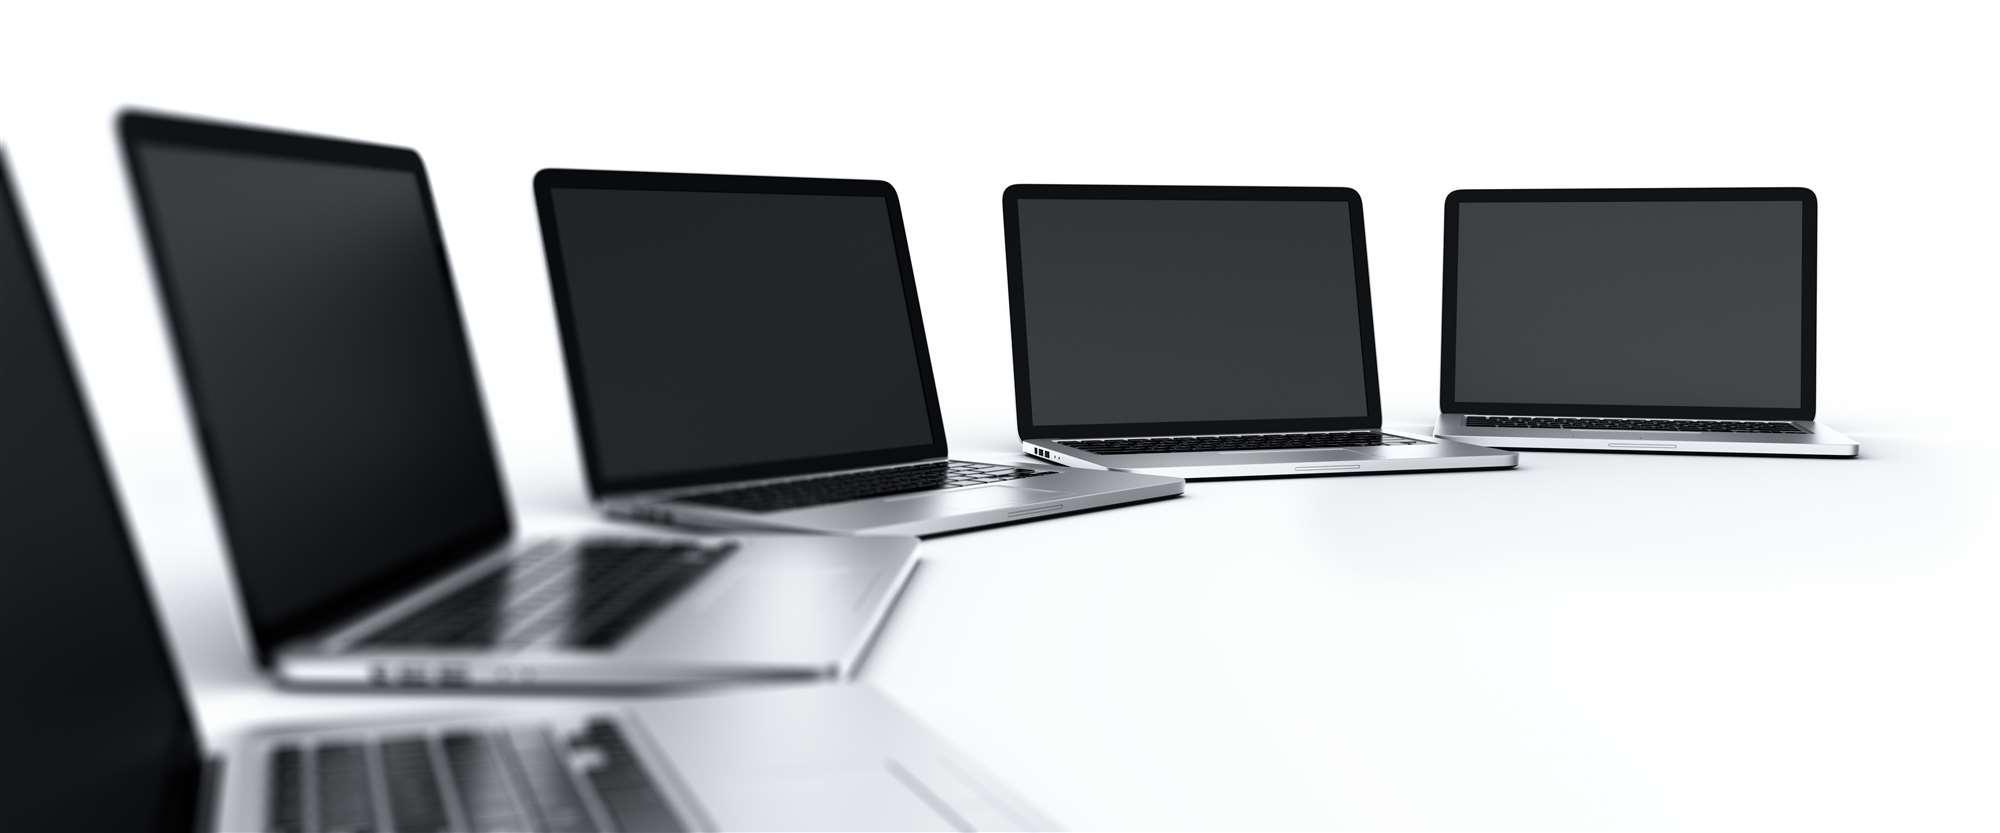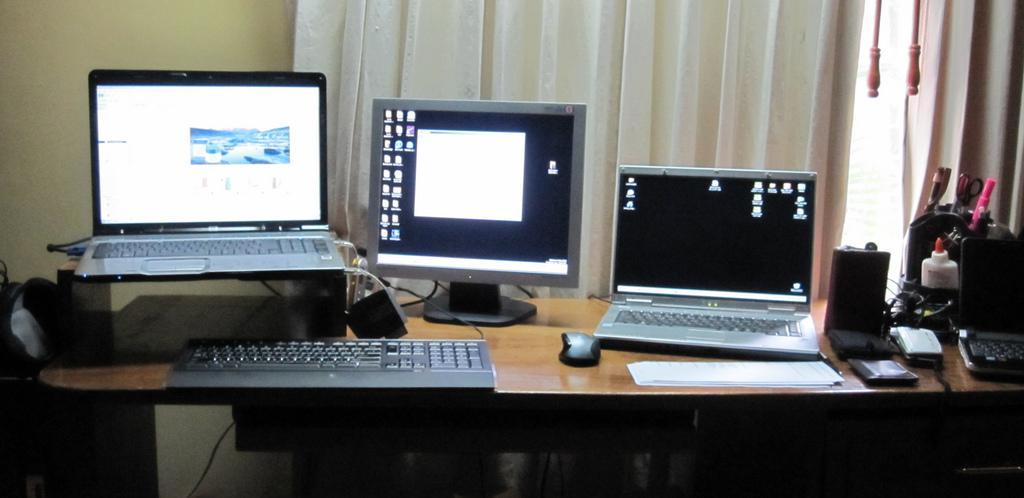The first image is the image on the left, the second image is the image on the right. Assess this claim about the two images: "One image shows a brown desk with three computer screens visible on top of it.". Correct or not? Answer yes or no. Yes. The first image is the image on the left, the second image is the image on the right. Evaluate the accuracy of this statement regarding the images: "Three computers are displayed in the image on the right.". Is it true? Answer yes or no. Yes. 